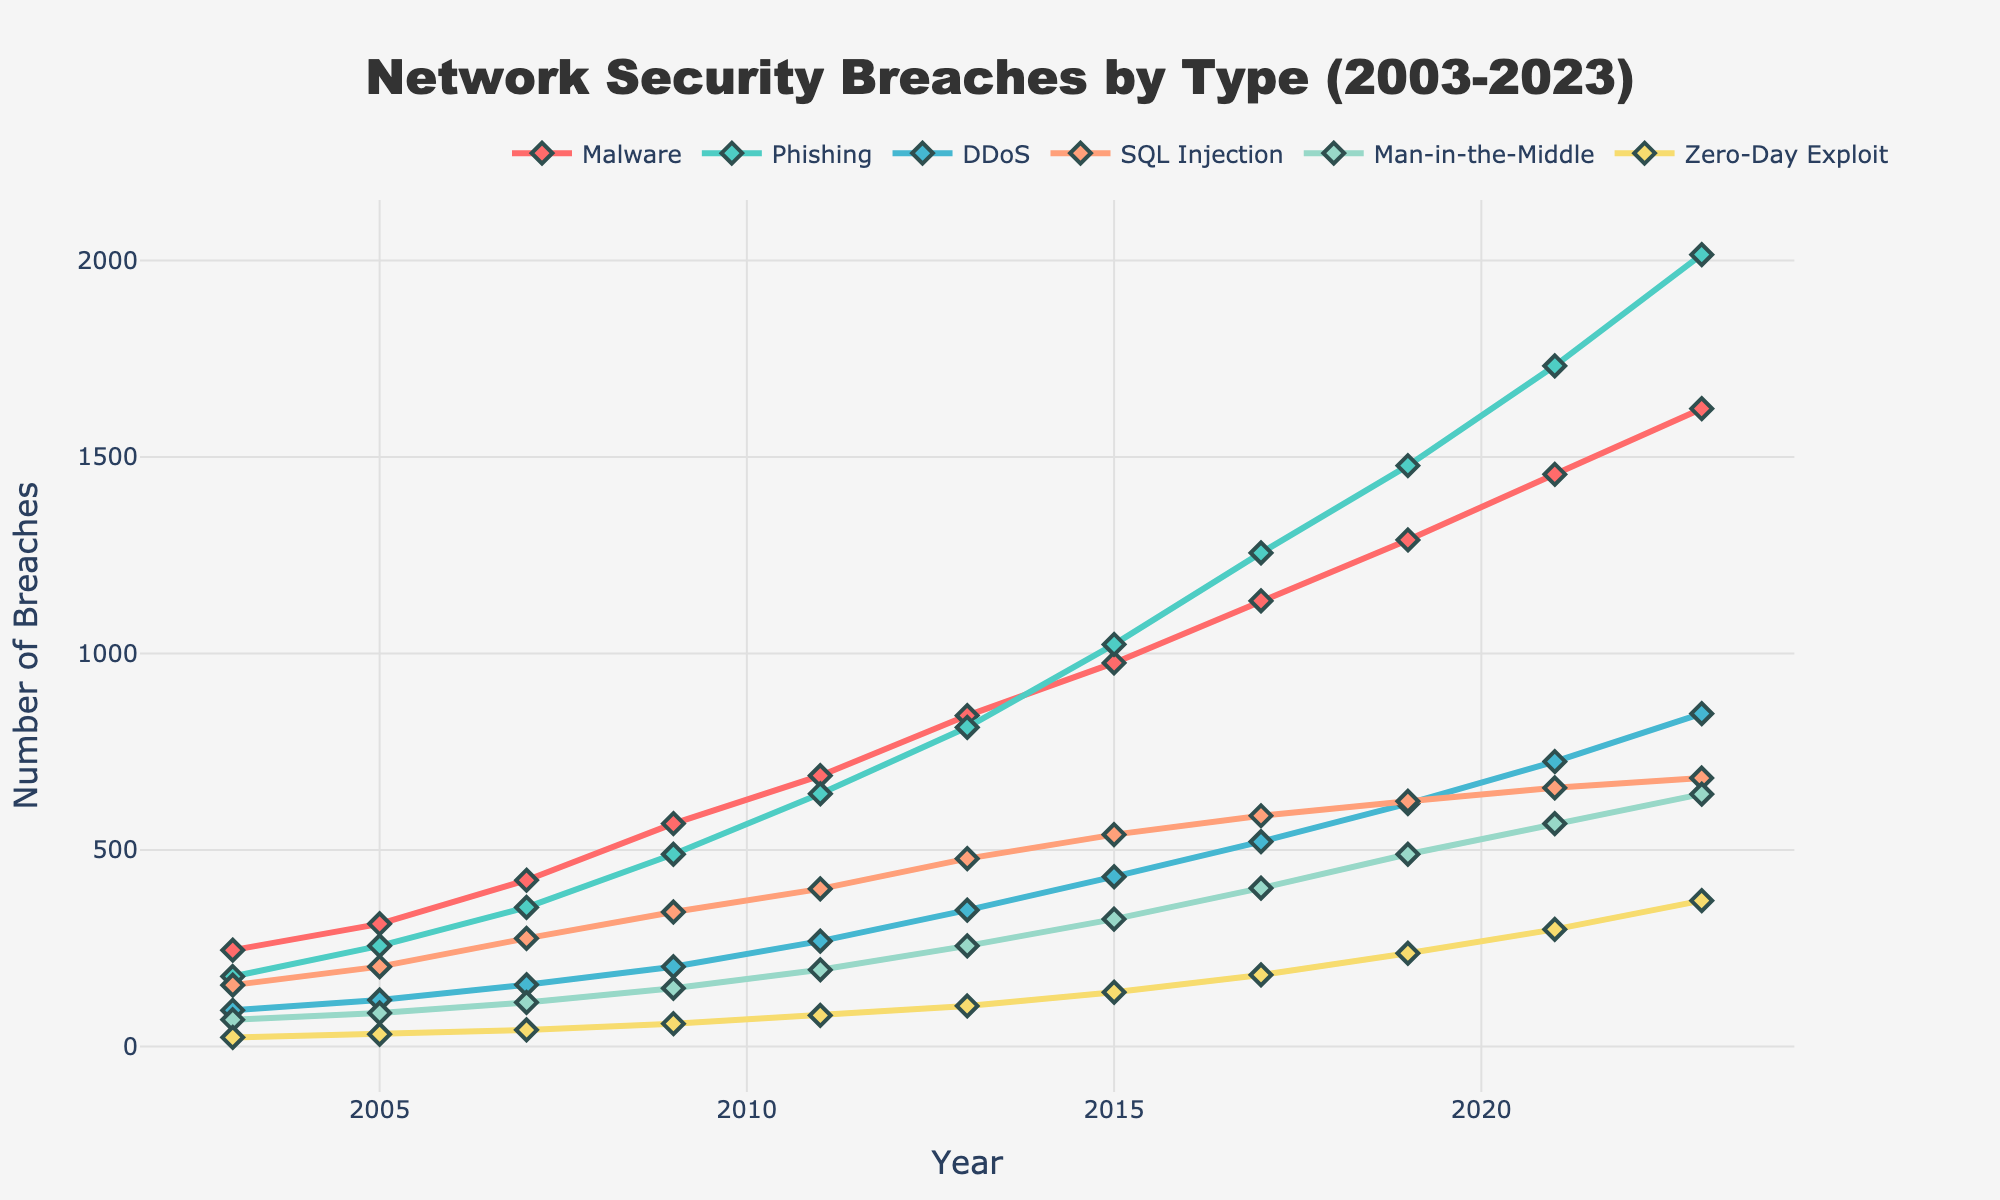What is the trend of malware breaches from 2003 to 2023? By observing the line representing malware breaches, we can see that it steadily increases from 2003 (245 breaches) to 2023 (1623 breaches), indicating a consistent upward trend over the two decades.
Answer: It increases Which year had the highest number of phishing breaches? By looking at the line for phishing breaches, the peak value occurs in 2023 with 2015 breaches, which is the highest number recorded for phishing within the dataset.
Answer: 2023 How does the number of DDoS breaches in 2023 compare to those in 2003? To compare, locate the DDoS breaches for both years: in 2003, there were 92 breaches, and in 2023, there were 847 breaches. Hence, the number of DDoS breaches significantly increased from 2003 to 2023.
Answer: It increased What is the combined total of zero-day exploits in 2005 and 2007? Add the number of zero-day exploits for 2005 (31 breaches) and 2007 (42 breaches). So, 31 + 42 = 73 breaches.
Answer: 73 Which breach type had the least number of incidents in 2011, and how many were there? By identifying the lowest point on the graph for 2011, we observe that the zero-day exploit line is at the lowest position, with 79 breaches.
Answer: Zero-day exploit, 79 Which breach type predominantly increased and overtook SQL Injection from 2013 onwards? From 2013 onwards, Phishing breaches (green line) show a significant increase compared to SQL Injection (pink line), which increased at a slower rate.
Answer: Phishing Between 2011 and 2017, which breach type had the highest growth rate? Calculate the difference between 2017 and 2011 for each breach type: Malware: (1134-689)/689 ≈ 0.65, Phishing: (1256-643)/643 ≈ 0.94, DDoS: (521-268)/268 ≈ 0.94, SQL Injection: (587-401)/401 ≈ 0.46, Man-in-the-Middle: (403-195)/195 ≈ 1.07, Zero-Day Exploit: (182-79)/79 ≈ 1.30. Zero-Day Exploit had the highest growth rate.
Answer: Zero-Day Exploit In which year did the number of phishing breaches overtake malware breaches? Check both lines for the first intersection point. This occurs in 2019, where the points for phishing (1478) and malware (1289) intersect, indicating phishing overtakes malware at this point.
Answer: 2019 